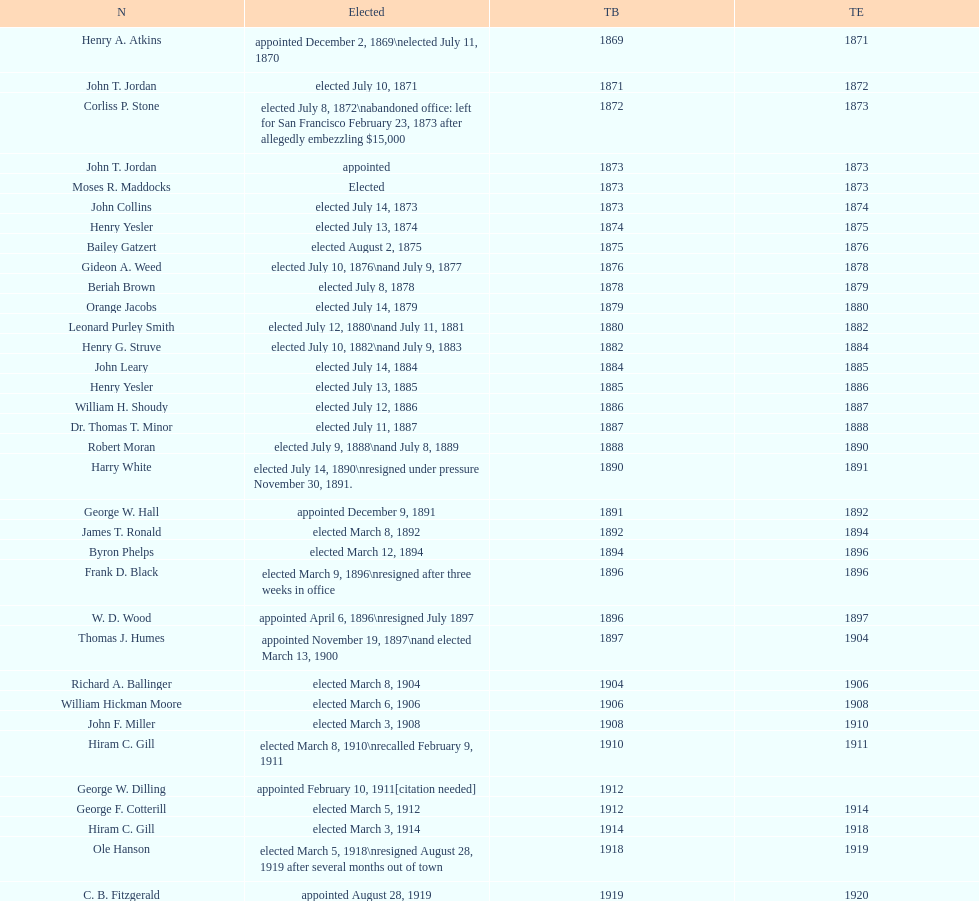Did charles royer hold office longer than paul schell? Yes. 